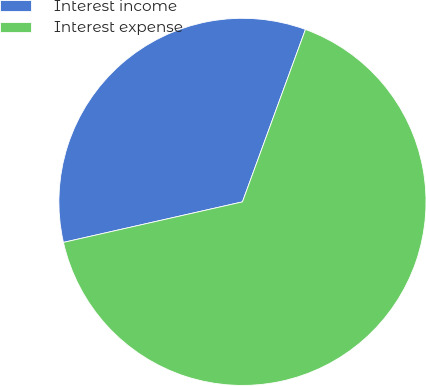Convert chart to OTSL. <chart><loc_0><loc_0><loc_500><loc_500><pie_chart><fcel>Interest income<fcel>Interest expense<nl><fcel>34.12%<fcel>65.88%<nl></chart> 